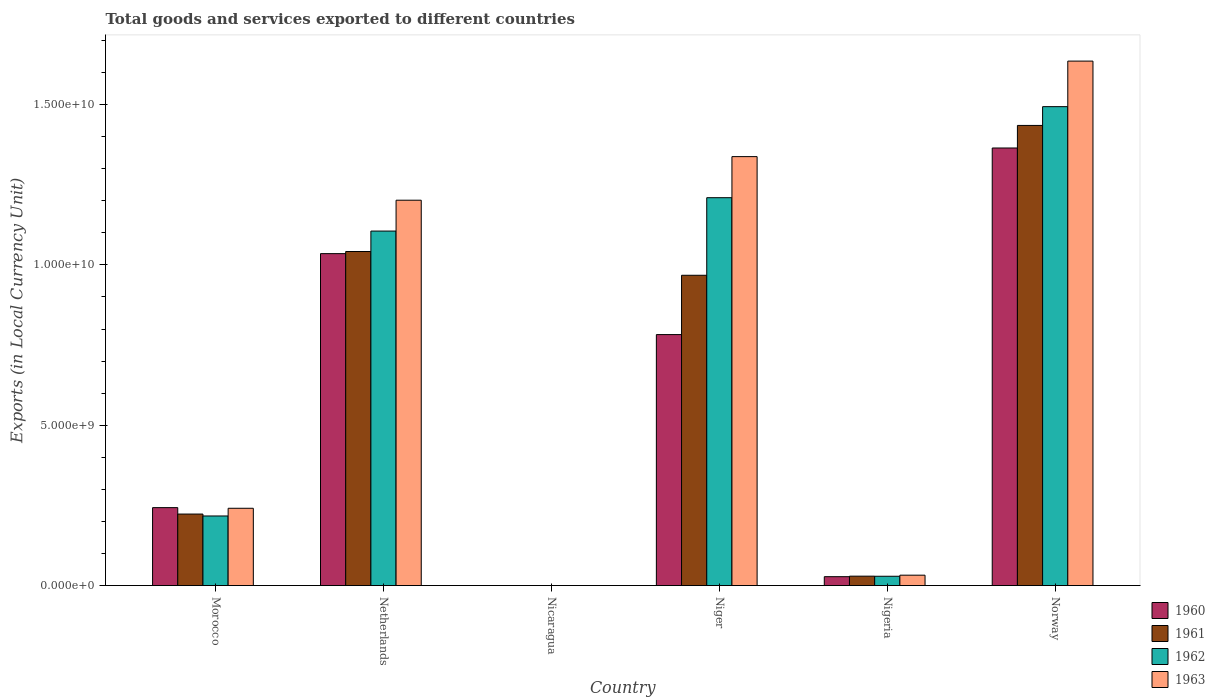How many different coloured bars are there?
Your response must be concise. 4. Are the number of bars per tick equal to the number of legend labels?
Make the answer very short. Yes. Are the number of bars on each tick of the X-axis equal?
Offer a very short reply. Yes. What is the Amount of goods and services exports in 1961 in Nigeria?
Provide a short and direct response. 2.93e+08. Across all countries, what is the maximum Amount of goods and services exports in 1963?
Make the answer very short. 1.64e+1. Across all countries, what is the minimum Amount of goods and services exports in 1963?
Offer a very short reply. 0.18. In which country was the Amount of goods and services exports in 1961 maximum?
Offer a terse response. Norway. In which country was the Amount of goods and services exports in 1963 minimum?
Offer a terse response. Nicaragua. What is the total Amount of goods and services exports in 1960 in the graph?
Make the answer very short. 3.45e+1. What is the difference between the Amount of goods and services exports in 1962 in Nicaragua and that in Niger?
Make the answer very short. -1.21e+1. What is the difference between the Amount of goods and services exports in 1960 in Nicaragua and the Amount of goods and services exports in 1961 in Morocco?
Provide a short and direct response. -2.23e+09. What is the average Amount of goods and services exports in 1963 per country?
Keep it short and to the point. 7.41e+09. What is the difference between the Amount of goods and services exports of/in 1961 and Amount of goods and services exports of/in 1962 in Norway?
Offer a terse response. -5.86e+08. In how many countries, is the Amount of goods and services exports in 1963 greater than 15000000000 LCU?
Offer a terse response. 1. What is the ratio of the Amount of goods and services exports in 1961 in Niger to that in Norway?
Offer a very short reply. 0.67. What is the difference between the highest and the second highest Amount of goods and services exports in 1963?
Your response must be concise. 4.34e+09. What is the difference between the highest and the lowest Amount of goods and services exports in 1961?
Your answer should be compact. 1.43e+1. In how many countries, is the Amount of goods and services exports in 1963 greater than the average Amount of goods and services exports in 1963 taken over all countries?
Ensure brevity in your answer.  3. Is the sum of the Amount of goods and services exports in 1961 in Morocco and Netherlands greater than the maximum Amount of goods and services exports in 1963 across all countries?
Your answer should be very brief. No. What does the 4th bar from the left in Netherlands represents?
Make the answer very short. 1963. What does the 2nd bar from the right in Nigeria represents?
Give a very brief answer. 1962. How many bars are there?
Provide a short and direct response. 24. Where does the legend appear in the graph?
Offer a very short reply. Bottom right. How are the legend labels stacked?
Your answer should be very brief. Vertical. What is the title of the graph?
Your response must be concise. Total goods and services exported to different countries. What is the label or title of the Y-axis?
Your response must be concise. Exports (in Local Currency Unit). What is the Exports (in Local Currency Unit) in 1960 in Morocco?
Keep it short and to the point. 2.43e+09. What is the Exports (in Local Currency Unit) of 1961 in Morocco?
Provide a short and direct response. 2.23e+09. What is the Exports (in Local Currency Unit) of 1962 in Morocco?
Provide a succinct answer. 2.17e+09. What is the Exports (in Local Currency Unit) of 1963 in Morocco?
Give a very brief answer. 2.41e+09. What is the Exports (in Local Currency Unit) in 1960 in Netherlands?
Keep it short and to the point. 1.04e+1. What is the Exports (in Local Currency Unit) of 1961 in Netherlands?
Provide a succinct answer. 1.04e+1. What is the Exports (in Local Currency Unit) of 1962 in Netherlands?
Your answer should be compact. 1.11e+1. What is the Exports (in Local Currency Unit) in 1963 in Netherlands?
Your answer should be very brief. 1.20e+1. What is the Exports (in Local Currency Unit) of 1960 in Nicaragua?
Provide a short and direct response. 0.11. What is the Exports (in Local Currency Unit) in 1961 in Nicaragua?
Your answer should be very brief. 0.12. What is the Exports (in Local Currency Unit) of 1962 in Nicaragua?
Offer a very short reply. 0.15. What is the Exports (in Local Currency Unit) of 1963 in Nicaragua?
Keep it short and to the point. 0.18. What is the Exports (in Local Currency Unit) in 1960 in Niger?
Your answer should be very brief. 7.83e+09. What is the Exports (in Local Currency Unit) of 1961 in Niger?
Your response must be concise. 9.68e+09. What is the Exports (in Local Currency Unit) in 1962 in Niger?
Provide a succinct answer. 1.21e+1. What is the Exports (in Local Currency Unit) of 1963 in Niger?
Offer a very short reply. 1.34e+1. What is the Exports (in Local Currency Unit) of 1960 in Nigeria?
Offer a terse response. 2.77e+08. What is the Exports (in Local Currency Unit) in 1961 in Nigeria?
Offer a terse response. 2.93e+08. What is the Exports (in Local Currency Unit) in 1962 in Nigeria?
Provide a short and direct response. 2.90e+08. What is the Exports (in Local Currency Unit) of 1963 in Nigeria?
Offer a terse response. 3.24e+08. What is the Exports (in Local Currency Unit) of 1960 in Norway?
Keep it short and to the point. 1.36e+1. What is the Exports (in Local Currency Unit) in 1961 in Norway?
Your answer should be very brief. 1.43e+1. What is the Exports (in Local Currency Unit) in 1962 in Norway?
Your answer should be very brief. 1.49e+1. What is the Exports (in Local Currency Unit) of 1963 in Norway?
Offer a terse response. 1.64e+1. Across all countries, what is the maximum Exports (in Local Currency Unit) of 1960?
Give a very brief answer. 1.36e+1. Across all countries, what is the maximum Exports (in Local Currency Unit) of 1961?
Your response must be concise. 1.43e+1. Across all countries, what is the maximum Exports (in Local Currency Unit) in 1962?
Your answer should be very brief. 1.49e+1. Across all countries, what is the maximum Exports (in Local Currency Unit) in 1963?
Offer a terse response. 1.64e+1. Across all countries, what is the minimum Exports (in Local Currency Unit) in 1960?
Offer a very short reply. 0.11. Across all countries, what is the minimum Exports (in Local Currency Unit) of 1961?
Ensure brevity in your answer.  0.12. Across all countries, what is the minimum Exports (in Local Currency Unit) in 1962?
Provide a short and direct response. 0.15. Across all countries, what is the minimum Exports (in Local Currency Unit) in 1963?
Your response must be concise. 0.18. What is the total Exports (in Local Currency Unit) in 1960 in the graph?
Your answer should be very brief. 3.45e+1. What is the total Exports (in Local Currency Unit) of 1961 in the graph?
Your answer should be very brief. 3.70e+1. What is the total Exports (in Local Currency Unit) in 1962 in the graph?
Provide a short and direct response. 4.05e+1. What is the total Exports (in Local Currency Unit) in 1963 in the graph?
Your answer should be compact. 4.45e+1. What is the difference between the Exports (in Local Currency Unit) of 1960 in Morocco and that in Netherlands?
Provide a short and direct response. -7.92e+09. What is the difference between the Exports (in Local Currency Unit) in 1961 in Morocco and that in Netherlands?
Keep it short and to the point. -8.19e+09. What is the difference between the Exports (in Local Currency Unit) of 1962 in Morocco and that in Netherlands?
Give a very brief answer. -8.88e+09. What is the difference between the Exports (in Local Currency Unit) in 1963 in Morocco and that in Netherlands?
Give a very brief answer. -9.61e+09. What is the difference between the Exports (in Local Currency Unit) in 1960 in Morocco and that in Nicaragua?
Your response must be concise. 2.43e+09. What is the difference between the Exports (in Local Currency Unit) in 1961 in Morocco and that in Nicaragua?
Provide a succinct answer. 2.23e+09. What is the difference between the Exports (in Local Currency Unit) in 1962 in Morocco and that in Nicaragua?
Make the answer very short. 2.17e+09. What is the difference between the Exports (in Local Currency Unit) in 1963 in Morocco and that in Nicaragua?
Keep it short and to the point. 2.41e+09. What is the difference between the Exports (in Local Currency Unit) in 1960 in Morocco and that in Niger?
Provide a succinct answer. -5.40e+09. What is the difference between the Exports (in Local Currency Unit) of 1961 in Morocco and that in Niger?
Make the answer very short. -7.45e+09. What is the difference between the Exports (in Local Currency Unit) in 1962 in Morocco and that in Niger?
Offer a terse response. -9.92e+09. What is the difference between the Exports (in Local Currency Unit) of 1963 in Morocco and that in Niger?
Offer a very short reply. -1.10e+1. What is the difference between the Exports (in Local Currency Unit) in 1960 in Morocco and that in Nigeria?
Offer a very short reply. 2.15e+09. What is the difference between the Exports (in Local Currency Unit) of 1961 in Morocco and that in Nigeria?
Offer a very short reply. 1.94e+09. What is the difference between the Exports (in Local Currency Unit) in 1962 in Morocco and that in Nigeria?
Make the answer very short. 1.88e+09. What is the difference between the Exports (in Local Currency Unit) in 1963 in Morocco and that in Nigeria?
Make the answer very short. 2.09e+09. What is the difference between the Exports (in Local Currency Unit) in 1960 in Morocco and that in Norway?
Offer a very short reply. -1.12e+1. What is the difference between the Exports (in Local Currency Unit) of 1961 in Morocco and that in Norway?
Ensure brevity in your answer.  -1.21e+1. What is the difference between the Exports (in Local Currency Unit) of 1962 in Morocco and that in Norway?
Provide a succinct answer. -1.28e+1. What is the difference between the Exports (in Local Currency Unit) in 1963 in Morocco and that in Norway?
Ensure brevity in your answer.  -1.39e+1. What is the difference between the Exports (in Local Currency Unit) in 1960 in Netherlands and that in Nicaragua?
Your response must be concise. 1.04e+1. What is the difference between the Exports (in Local Currency Unit) of 1961 in Netherlands and that in Nicaragua?
Provide a short and direct response. 1.04e+1. What is the difference between the Exports (in Local Currency Unit) of 1962 in Netherlands and that in Nicaragua?
Offer a terse response. 1.11e+1. What is the difference between the Exports (in Local Currency Unit) in 1963 in Netherlands and that in Nicaragua?
Provide a succinct answer. 1.20e+1. What is the difference between the Exports (in Local Currency Unit) of 1960 in Netherlands and that in Niger?
Offer a very short reply. 2.52e+09. What is the difference between the Exports (in Local Currency Unit) in 1961 in Netherlands and that in Niger?
Keep it short and to the point. 7.41e+08. What is the difference between the Exports (in Local Currency Unit) in 1962 in Netherlands and that in Niger?
Keep it short and to the point. -1.04e+09. What is the difference between the Exports (in Local Currency Unit) of 1963 in Netherlands and that in Niger?
Provide a succinct answer. -1.36e+09. What is the difference between the Exports (in Local Currency Unit) of 1960 in Netherlands and that in Nigeria?
Provide a succinct answer. 1.01e+1. What is the difference between the Exports (in Local Currency Unit) of 1961 in Netherlands and that in Nigeria?
Offer a terse response. 1.01e+1. What is the difference between the Exports (in Local Currency Unit) of 1962 in Netherlands and that in Nigeria?
Give a very brief answer. 1.08e+1. What is the difference between the Exports (in Local Currency Unit) of 1963 in Netherlands and that in Nigeria?
Provide a short and direct response. 1.17e+1. What is the difference between the Exports (in Local Currency Unit) of 1960 in Netherlands and that in Norway?
Keep it short and to the point. -3.29e+09. What is the difference between the Exports (in Local Currency Unit) in 1961 in Netherlands and that in Norway?
Your answer should be very brief. -3.93e+09. What is the difference between the Exports (in Local Currency Unit) of 1962 in Netherlands and that in Norway?
Your answer should be very brief. -3.88e+09. What is the difference between the Exports (in Local Currency Unit) in 1963 in Netherlands and that in Norway?
Your answer should be very brief. -4.34e+09. What is the difference between the Exports (in Local Currency Unit) in 1960 in Nicaragua and that in Niger?
Provide a short and direct response. -7.83e+09. What is the difference between the Exports (in Local Currency Unit) of 1961 in Nicaragua and that in Niger?
Provide a short and direct response. -9.68e+09. What is the difference between the Exports (in Local Currency Unit) in 1962 in Nicaragua and that in Niger?
Your answer should be very brief. -1.21e+1. What is the difference between the Exports (in Local Currency Unit) of 1963 in Nicaragua and that in Niger?
Make the answer very short. -1.34e+1. What is the difference between the Exports (in Local Currency Unit) of 1960 in Nicaragua and that in Nigeria?
Keep it short and to the point. -2.77e+08. What is the difference between the Exports (in Local Currency Unit) in 1961 in Nicaragua and that in Nigeria?
Your response must be concise. -2.93e+08. What is the difference between the Exports (in Local Currency Unit) of 1962 in Nicaragua and that in Nigeria?
Make the answer very short. -2.90e+08. What is the difference between the Exports (in Local Currency Unit) in 1963 in Nicaragua and that in Nigeria?
Offer a very short reply. -3.24e+08. What is the difference between the Exports (in Local Currency Unit) of 1960 in Nicaragua and that in Norway?
Provide a short and direct response. -1.36e+1. What is the difference between the Exports (in Local Currency Unit) in 1961 in Nicaragua and that in Norway?
Give a very brief answer. -1.43e+1. What is the difference between the Exports (in Local Currency Unit) of 1962 in Nicaragua and that in Norway?
Your answer should be compact. -1.49e+1. What is the difference between the Exports (in Local Currency Unit) of 1963 in Nicaragua and that in Norway?
Offer a terse response. -1.64e+1. What is the difference between the Exports (in Local Currency Unit) in 1960 in Niger and that in Nigeria?
Provide a short and direct response. 7.55e+09. What is the difference between the Exports (in Local Currency Unit) of 1961 in Niger and that in Nigeria?
Your answer should be compact. 9.38e+09. What is the difference between the Exports (in Local Currency Unit) in 1962 in Niger and that in Nigeria?
Offer a very short reply. 1.18e+1. What is the difference between the Exports (in Local Currency Unit) in 1963 in Niger and that in Nigeria?
Offer a terse response. 1.31e+1. What is the difference between the Exports (in Local Currency Unit) in 1960 in Niger and that in Norway?
Provide a succinct answer. -5.82e+09. What is the difference between the Exports (in Local Currency Unit) in 1961 in Niger and that in Norway?
Give a very brief answer. -4.67e+09. What is the difference between the Exports (in Local Currency Unit) of 1962 in Niger and that in Norway?
Keep it short and to the point. -2.84e+09. What is the difference between the Exports (in Local Currency Unit) of 1963 in Niger and that in Norway?
Your answer should be compact. -2.98e+09. What is the difference between the Exports (in Local Currency Unit) in 1960 in Nigeria and that in Norway?
Offer a terse response. -1.34e+1. What is the difference between the Exports (in Local Currency Unit) of 1961 in Nigeria and that in Norway?
Your answer should be very brief. -1.41e+1. What is the difference between the Exports (in Local Currency Unit) in 1962 in Nigeria and that in Norway?
Provide a short and direct response. -1.46e+1. What is the difference between the Exports (in Local Currency Unit) of 1963 in Nigeria and that in Norway?
Make the answer very short. -1.60e+1. What is the difference between the Exports (in Local Currency Unit) of 1960 in Morocco and the Exports (in Local Currency Unit) of 1961 in Netherlands?
Make the answer very short. -7.99e+09. What is the difference between the Exports (in Local Currency Unit) of 1960 in Morocco and the Exports (in Local Currency Unit) of 1962 in Netherlands?
Keep it short and to the point. -8.62e+09. What is the difference between the Exports (in Local Currency Unit) of 1960 in Morocco and the Exports (in Local Currency Unit) of 1963 in Netherlands?
Offer a terse response. -9.59e+09. What is the difference between the Exports (in Local Currency Unit) in 1961 in Morocco and the Exports (in Local Currency Unit) in 1962 in Netherlands?
Provide a succinct answer. -8.82e+09. What is the difference between the Exports (in Local Currency Unit) in 1961 in Morocco and the Exports (in Local Currency Unit) in 1963 in Netherlands?
Provide a succinct answer. -9.79e+09. What is the difference between the Exports (in Local Currency Unit) of 1962 in Morocco and the Exports (in Local Currency Unit) of 1963 in Netherlands?
Offer a terse response. -9.85e+09. What is the difference between the Exports (in Local Currency Unit) in 1960 in Morocco and the Exports (in Local Currency Unit) in 1961 in Nicaragua?
Offer a terse response. 2.43e+09. What is the difference between the Exports (in Local Currency Unit) in 1960 in Morocco and the Exports (in Local Currency Unit) in 1962 in Nicaragua?
Provide a succinct answer. 2.43e+09. What is the difference between the Exports (in Local Currency Unit) in 1960 in Morocco and the Exports (in Local Currency Unit) in 1963 in Nicaragua?
Keep it short and to the point. 2.43e+09. What is the difference between the Exports (in Local Currency Unit) in 1961 in Morocco and the Exports (in Local Currency Unit) in 1962 in Nicaragua?
Your answer should be compact. 2.23e+09. What is the difference between the Exports (in Local Currency Unit) of 1961 in Morocco and the Exports (in Local Currency Unit) of 1963 in Nicaragua?
Ensure brevity in your answer.  2.23e+09. What is the difference between the Exports (in Local Currency Unit) in 1962 in Morocco and the Exports (in Local Currency Unit) in 1963 in Nicaragua?
Provide a succinct answer. 2.17e+09. What is the difference between the Exports (in Local Currency Unit) of 1960 in Morocco and the Exports (in Local Currency Unit) of 1961 in Niger?
Your answer should be compact. -7.25e+09. What is the difference between the Exports (in Local Currency Unit) in 1960 in Morocco and the Exports (in Local Currency Unit) in 1962 in Niger?
Offer a terse response. -9.66e+09. What is the difference between the Exports (in Local Currency Unit) in 1960 in Morocco and the Exports (in Local Currency Unit) in 1963 in Niger?
Ensure brevity in your answer.  -1.09e+1. What is the difference between the Exports (in Local Currency Unit) of 1961 in Morocco and the Exports (in Local Currency Unit) of 1962 in Niger?
Provide a short and direct response. -9.86e+09. What is the difference between the Exports (in Local Currency Unit) in 1961 in Morocco and the Exports (in Local Currency Unit) in 1963 in Niger?
Offer a terse response. -1.11e+1. What is the difference between the Exports (in Local Currency Unit) of 1962 in Morocco and the Exports (in Local Currency Unit) of 1963 in Niger?
Your response must be concise. -1.12e+1. What is the difference between the Exports (in Local Currency Unit) in 1960 in Morocco and the Exports (in Local Currency Unit) in 1961 in Nigeria?
Give a very brief answer. 2.14e+09. What is the difference between the Exports (in Local Currency Unit) of 1960 in Morocco and the Exports (in Local Currency Unit) of 1962 in Nigeria?
Your answer should be compact. 2.14e+09. What is the difference between the Exports (in Local Currency Unit) in 1960 in Morocco and the Exports (in Local Currency Unit) in 1963 in Nigeria?
Your response must be concise. 2.11e+09. What is the difference between the Exports (in Local Currency Unit) in 1961 in Morocco and the Exports (in Local Currency Unit) in 1962 in Nigeria?
Your response must be concise. 1.94e+09. What is the difference between the Exports (in Local Currency Unit) of 1961 in Morocco and the Exports (in Local Currency Unit) of 1963 in Nigeria?
Ensure brevity in your answer.  1.91e+09. What is the difference between the Exports (in Local Currency Unit) of 1962 in Morocco and the Exports (in Local Currency Unit) of 1963 in Nigeria?
Offer a very short reply. 1.85e+09. What is the difference between the Exports (in Local Currency Unit) of 1960 in Morocco and the Exports (in Local Currency Unit) of 1961 in Norway?
Your response must be concise. -1.19e+1. What is the difference between the Exports (in Local Currency Unit) of 1960 in Morocco and the Exports (in Local Currency Unit) of 1962 in Norway?
Make the answer very short. -1.25e+1. What is the difference between the Exports (in Local Currency Unit) of 1960 in Morocco and the Exports (in Local Currency Unit) of 1963 in Norway?
Ensure brevity in your answer.  -1.39e+1. What is the difference between the Exports (in Local Currency Unit) in 1961 in Morocco and the Exports (in Local Currency Unit) in 1962 in Norway?
Give a very brief answer. -1.27e+1. What is the difference between the Exports (in Local Currency Unit) in 1961 in Morocco and the Exports (in Local Currency Unit) in 1963 in Norway?
Offer a terse response. -1.41e+1. What is the difference between the Exports (in Local Currency Unit) in 1962 in Morocco and the Exports (in Local Currency Unit) in 1963 in Norway?
Make the answer very short. -1.42e+1. What is the difference between the Exports (in Local Currency Unit) in 1960 in Netherlands and the Exports (in Local Currency Unit) in 1961 in Nicaragua?
Offer a very short reply. 1.04e+1. What is the difference between the Exports (in Local Currency Unit) of 1960 in Netherlands and the Exports (in Local Currency Unit) of 1962 in Nicaragua?
Your answer should be compact. 1.04e+1. What is the difference between the Exports (in Local Currency Unit) in 1960 in Netherlands and the Exports (in Local Currency Unit) in 1963 in Nicaragua?
Your response must be concise. 1.04e+1. What is the difference between the Exports (in Local Currency Unit) of 1961 in Netherlands and the Exports (in Local Currency Unit) of 1962 in Nicaragua?
Provide a succinct answer. 1.04e+1. What is the difference between the Exports (in Local Currency Unit) of 1961 in Netherlands and the Exports (in Local Currency Unit) of 1963 in Nicaragua?
Offer a very short reply. 1.04e+1. What is the difference between the Exports (in Local Currency Unit) of 1962 in Netherlands and the Exports (in Local Currency Unit) of 1963 in Nicaragua?
Ensure brevity in your answer.  1.11e+1. What is the difference between the Exports (in Local Currency Unit) of 1960 in Netherlands and the Exports (in Local Currency Unit) of 1961 in Niger?
Offer a very short reply. 6.75e+08. What is the difference between the Exports (in Local Currency Unit) in 1960 in Netherlands and the Exports (in Local Currency Unit) in 1962 in Niger?
Make the answer very short. -1.74e+09. What is the difference between the Exports (in Local Currency Unit) of 1960 in Netherlands and the Exports (in Local Currency Unit) of 1963 in Niger?
Ensure brevity in your answer.  -3.02e+09. What is the difference between the Exports (in Local Currency Unit) in 1961 in Netherlands and the Exports (in Local Currency Unit) in 1962 in Niger?
Provide a short and direct response. -1.68e+09. What is the difference between the Exports (in Local Currency Unit) of 1961 in Netherlands and the Exports (in Local Currency Unit) of 1963 in Niger?
Your response must be concise. -2.96e+09. What is the difference between the Exports (in Local Currency Unit) of 1962 in Netherlands and the Exports (in Local Currency Unit) of 1963 in Niger?
Your answer should be very brief. -2.32e+09. What is the difference between the Exports (in Local Currency Unit) in 1960 in Netherlands and the Exports (in Local Currency Unit) in 1961 in Nigeria?
Provide a succinct answer. 1.01e+1. What is the difference between the Exports (in Local Currency Unit) in 1960 in Netherlands and the Exports (in Local Currency Unit) in 1962 in Nigeria?
Offer a terse response. 1.01e+1. What is the difference between the Exports (in Local Currency Unit) of 1960 in Netherlands and the Exports (in Local Currency Unit) of 1963 in Nigeria?
Provide a short and direct response. 1.00e+1. What is the difference between the Exports (in Local Currency Unit) in 1961 in Netherlands and the Exports (in Local Currency Unit) in 1962 in Nigeria?
Provide a short and direct response. 1.01e+1. What is the difference between the Exports (in Local Currency Unit) in 1961 in Netherlands and the Exports (in Local Currency Unit) in 1963 in Nigeria?
Make the answer very short. 1.01e+1. What is the difference between the Exports (in Local Currency Unit) in 1962 in Netherlands and the Exports (in Local Currency Unit) in 1963 in Nigeria?
Make the answer very short. 1.07e+1. What is the difference between the Exports (in Local Currency Unit) in 1960 in Netherlands and the Exports (in Local Currency Unit) in 1961 in Norway?
Your answer should be compact. -4.00e+09. What is the difference between the Exports (in Local Currency Unit) of 1960 in Netherlands and the Exports (in Local Currency Unit) of 1962 in Norway?
Ensure brevity in your answer.  -4.58e+09. What is the difference between the Exports (in Local Currency Unit) of 1960 in Netherlands and the Exports (in Local Currency Unit) of 1963 in Norway?
Your answer should be very brief. -6.00e+09. What is the difference between the Exports (in Local Currency Unit) of 1961 in Netherlands and the Exports (in Local Currency Unit) of 1962 in Norway?
Ensure brevity in your answer.  -4.52e+09. What is the difference between the Exports (in Local Currency Unit) of 1961 in Netherlands and the Exports (in Local Currency Unit) of 1963 in Norway?
Your answer should be compact. -5.94e+09. What is the difference between the Exports (in Local Currency Unit) in 1962 in Netherlands and the Exports (in Local Currency Unit) in 1963 in Norway?
Your answer should be very brief. -5.30e+09. What is the difference between the Exports (in Local Currency Unit) of 1960 in Nicaragua and the Exports (in Local Currency Unit) of 1961 in Niger?
Provide a succinct answer. -9.68e+09. What is the difference between the Exports (in Local Currency Unit) in 1960 in Nicaragua and the Exports (in Local Currency Unit) in 1962 in Niger?
Give a very brief answer. -1.21e+1. What is the difference between the Exports (in Local Currency Unit) of 1960 in Nicaragua and the Exports (in Local Currency Unit) of 1963 in Niger?
Ensure brevity in your answer.  -1.34e+1. What is the difference between the Exports (in Local Currency Unit) of 1961 in Nicaragua and the Exports (in Local Currency Unit) of 1962 in Niger?
Ensure brevity in your answer.  -1.21e+1. What is the difference between the Exports (in Local Currency Unit) in 1961 in Nicaragua and the Exports (in Local Currency Unit) in 1963 in Niger?
Ensure brevity in your answer.  -1.34e+1. What is the difference between the Exports (in Local Currency Unit) of 1962 in Nicaragua and the Exports (in Local Currency Unit) of 1963 in Niger?
Make the answer very short. -1.34e+1. What is the difference between the Exports (in Local Currency Unit) in 1960 in Nicaragua and the Exports (in Local Currency Unit) in 1961 in Nigeria?
Make the answer very short. -2.93e+08. What is the difference between the Exports (in Local Currency Unit) of 1960 in Nicaragua and the Exports (in Local Currency Unit) of 1962 in Nigeria?
Offer a very short reply. -2.90e+08. What is the difference between the Exports (in Local Currency Unit) of 1960 in Nicaragua and the Exports (in Local Currency Unit) of 1963 in Nigeria?
Ensure brevity in your answer.  -3.24e+08. What is the difference between the Exports (in Local Currency Unit) of 1961 in Nicaragua and the Exports (in Local Currency Unit) of 1962 in Nigeria?
Your response must be concise. -2.90e+08. What is the difference between the Exports (in Local Currency Unit) in 1961 in Nicaragua and the Exports (in Local Currency Unit) in 1963 in Nigeria?
Ensure brevity in your answer.  -3.24e+08. What is the difference between the Exports (in Local Currency Unit) of 1962 in Nicaragua and the Exports (in Local Currency Unit) of 1963 in Nigeria?
Your answer should be very brief. -3.24e+08. What is the difference between the Exports (in Local Currency Unit) in 1960 in Nicaragua and the Exports (in Local Currency Unit) in 1961 in Norway?
Provide a succinct answer. -1.43e+1. What is the difference between the Exports (in Local Currency Unit) of 1960 in Nicaragua and the Exports (in Local Currency Unit) of 1962 in Norway?
Keep it short and to the point. -1.49e+1. What is the difference between the Exports (in Local Currency Unit) in 1960 in Nicaragua and the Exports (in Local Currency Unit) in 1963 in Norway?
Keep it short and to the point. -1.64e+1. What is the difference between the Exports (in Local Currency Unit) in 1961 in Nicaragua and the Exports (in Local Currency Unit) in 1962 in Norway?
Your answer should be compact. -1.49e+1. What is the difference between the Exports (in Local Currency Unit) in 1961 in Nicaragua and the Exports (in Local Currency Unit) in 1963 in Norway?
Your answer should be compact. -1.64e+1. What is the difference between the Exports (in Local Currency Unit) in 1962 in Nicaragua and the Exports (in Local Currency Unit) in 1963 in Norway?
Your answer should be compact. -1.64e+1. What is the difference between the Exports (in Local Currency Unit) in 1960 in Niger and the Exports (in Local Currency Unit) in 1961 in Nigeria?
Your response must be concise. 7.53e+09. What is the difference between the Exports (in Local Currency Unit) in 1960 in Niger and the Exports (in Local Currency Unit) in 1962 in Nigeria?
Your response must be concise. 7.54e+09. What is the difference between the Exports (in Local Currency Unit) of 1960 in Niger and the Exports (in Local Currency Unit) of 1963 in Nigeria?
Offer a very short reply. 7.50e+09. What is the difference between the Exports (in Local Currency Unit) of 1961 in Niger and the Exports (in Local Currency Unit) of 1962 in Nigeria?
Offer a terse response. 9.39e+09. What is the difference between the Exports (in Local Currency Unit) of 1961 in Niger and the Exports (in Local Currency Unit) of 1963 in Nigeria?
Ensure brevity in your answer.  9.35e+09. What is the difference between the Exports (in Local Currency Unit) of 1962 in Niger and the Exports (in Local Currency Unit) of 1963 in Nigeria?
Keep it short and to the point. 1.18e+1. What is the difference between the Exports (in Local Currency Unit) in 1960 in Niger and the Exports (in Local Currency Unit) in 1961 in Norway?
Provide a short and direct response. -6.52e+09. What is the difference between the Exports (in Local Currency Unit) of 1960 in Niger and the Exports (in Local Currency Unit) of 1962 in Norway?
Your answer should be compact. -7.11e+09. What is the difference between the Exports (in Local Currency Unit) of 1960 in Niger and the Exports (in Local Currency Unit) of 1963 in Norway?
Offer a very short reply. -8.53e+09. What is the difference between the Exports (in Local Currency Unit) of 1961 in Niger and the Exports (in Local Currency Unit) of 1962 in Norway?
Offer a very short reply. -5.26e+09. What is the difference between the Exports (in Local Currency Unit) of 1961 in Niger and the Exports (in Local Currency Unit) of 1963 in Norway?
Keep it short and to the point. -6.68e+09. What is the difference between the Exports (in Local Currency Unit) in 1962 in Niger and the Exports (in Local Currency Unit) in 1963 in Norway?
Offer a terse response. -4.26e+09. What is the difference between the Exports (in Local Currency Unit) in 1960 in Nigeria and the Exports (in Local Currency Unit) in 1961 in Norway?
Keep it short and to the point. -1.41e+1. What is the difference between the Exports (in Local Currency Unit) in 1960 in Nigeria and the Exports (in Local Currency Unit) in 1962 in Norway?
Offer a terse response. -1.47e+1. What is the difference between the Exports (in Local Currency Unit) in 1960 in Nigeria and the Exports (in Local Currency Unit) in 1963 in Norway?
Offer a terse response. -1.61e+1. What is the difference between the Exports (in Local Currency Unit) of 1961 in Nigeria and the Exports (in Local Currency Unit) of 1962 in Norway?
Ensure brevity in your answer.  -1.46e+1. What is the difference between the Exports (in Local Currency Unit) in 1961 in Nigeria and the Exports (in Local Currency Unit) in 1963 in Norway?
Your answer should be compact. -1.61e+1. What is the difference between the Exports (in Local Currency Unit) of 1962 in Nigeria and the Exports (in Local Currency Unit) of 1963 in Norway?
Your answer should be very brief. -1.61e+1. What is the average Exports (in Local Currency Unit) of 1960 per country?
Provide a succinct answer. 5.75e+09. What is the average Exports (in Local Currency Unit) in 1961 per country?
Your answer should be compact. 6.16e+09. What is the average Exports (in Local Currency Unit) of 1962 per country?
Your answer should be compact. 6.76e+09. What is the average Exports (in Local Currency Unit) in 1963 per country?
Make the answer very short. 7.41e+09. What is the difference between the Exports (in Local Currency Unit) in 1960 and Exports (in Local Currency Unit) in 1961 in Morocco?
Offer a very short reply. 2.00e+08. What is the difference between the Exports (in Local Currency Unit) in 1960 and Exports (in Local Currency Unit) in 1962 in Morocco?
Offer a terse response. 2.60e+08. What is the difference between the Exports (in Local Currency Unit) in 1961 and Exports (in Local Currency Unit) in 1962 in Morocco?
Your answer should be very brief. 6.00e+07. What is the difference between the Exports (in Local Currency Unit) of 1961 and Exports (in Local Currency Unit) of 1963 in Morocco?
Your answer should be compact. -1.80e+08. What is the difference between the Exports (in Local Currency Unit) in 1962 and Exports (in Local Currency Unit) in 1963 in Morocco?
Your response must be concise. -2.40e+08. What is the difference between the Exports (in Local Currency Unit) of 1960 and Exports (in Local Currency Unit) of 1961 in Netherlands?
Ensure brevity in your answer.  -6.60e+07. What is the difference between the Exports (in Local Currency Unit) of 1960 and Exports (in Local Currency Unit) of 1962 in Netherlands?
Your answer should be compact. -7.03e+08. What is the difference between the Exports (in Local Currency Unit) of 1960 and Exports (in Local Currency Unit) of 1963 in Netherlands?
Keep it short and to the point. -1.67e+09. What is the difference between the Exports (in Local Currency Unit) of 1961 and Exports (in Local Currency Unit) of 1962 in Netherlands?
Keep it short and to the point. -6.37e+08. What is the difference between the Exports (in Local Currency Unit) in 1961 and Exports (in Local Currency Unit) in 1963 in Netherlands?
Keep it short and to the point. -1.60e+09. What is the difference between the Exports (in Local Currency Unit) in 1962 and Exports (in Local Currency Unit) in 1963 in Netherlands?
Provide a succinct answer. -9.62e+08. What is the difference between the Exports (in Local Currency Unit) of 1960 and Exports (in Local Currency Unit) of 1961 in Nicaragua?
Your answer should be compact. -0.01. What is the difference between the Exports (in Local Currency Unit) of 1960 and Exports (in Local Currency Unit) of 1962 in Nicaragua?
Your response must be concise. -0.04. What is the difference between the Exports (in Local Currency Unit) in 1960 and Exports (in Local Currency Unit) in 1963 in Nicaragua?
Provide a short and direct response. -0.07. What is the difference between the Exports (in Local Currency Unit) of 1961 and Exports (in Local Currency Unit) of 1962 in Nicaragua?
Your response must be concise. -0.03. What is the difference between the Exports (in Local Currency Unit) in 1961 and Exports (in Local Currency Unit) in 1963 in Nicaragua?
Your answer should be very brief. -0.06. What is the difference between the Exports (in Local Currency Unit) of 1962 and Exports (in Local Currency Unit) of 1963 in Nicaragua?
Offer a very short reply. -0.03. What is the difference between the Exports (in Local Currency Unit) of 1960 and Exports (in Local Currency Unit) of 1961 in Niger?
Provide a short and direct response. -1.85e+09. What is the difference between the Exports (in Local Currency Unit) in 1960 and Exports (in Local Currency Unit) in 1962 in Niger?
Offer a terse response. -4.27e+09. What is the difference between the Exports (in Local Currency Unit) of 1960 and Exports (in Local Currency Unit) of 1963 in Niger?
Keep it short and to the point. -5.55e+09. What is the difference between the Exports (in Local Currency Unit) in 1961 and Exports (in Local Currency Unit) in 1962 in Niger?
Ensure brevity in your answer.  -2.42e+09. What is the difference between the Exports (in Local Currency Unit) of 1961 and Exports (in Local Currency Unit) of 1963 in Niger?
Offer a very short reply. -3.70e+09. What is the difference between the Exports (in Local Currency Unit) in 1962 and Exports (in Local Currency Unit) in 1963 in Niger?
Your answer should be very brief. -1.28e+09. What is the difference between the Exports (in Local Currency Unit) in 1960 and Exports (in Local Currency Unit) in 1961 in Nigeria?
Give a very brief answer. -1.61e+07. What is the difference between the Exports (in Local Currency Unit) in 1960 and Exports (in Local Currency Unit) in 1962 in Nigeria?
Offer a very short reply. -1.30e+07. What is the difference between the Exports (in Local Currency Unit) in 1960 and Exports (in Local Currency Unit) in 1963 in Nigeria?
Make the answer very short. -4.69e+07. What is the difference between the Exports (in Local Currency Unit) of 1961 and Exports (in Local Currency Unit) of 1962 in Nigeria?
Provide a short and direct response. 3.12e+06. What is the difference between the Exports (in Local Currency Unit) of 1961 and Exports (in Local Currency Unit) of 1963 in Nigeria?
Offer a very short reply. -3.08e+07. What is the difference between the Exports (in Local Currency Unit) in 1962 and Exports (in Local Currency Unit) in 1963 in Nigeria?
Offer a terse response. -3.40e+07. What is the difference between the Exports (in Local Currency Unit) in 1960 and Exports (in Local Currency Unit) in 1961 in Norway?
Give a very brief answer. -7.04e+08. What is the difference between the Exports (in Local Currency Unit) of 1960 and Exports (in Local Currency Unit) of 1962 in Norway?
Give a very brief answer. -1.29e+09. What is the difference between the Exports (in Local Currency Unit) in 1960 and Exports (in Local Currency Unit) in 1963 in Norway?
Offer a very short reply. -2.71e+09. What is the difference between the Exports (in Local Currency Unit) in 1961 and Exports (in Local Currency Unit) in 1962 in Norway?
Your answer should be very brief. -5.86e+08. What is the difference between the Exports (in Local Currency Unit) in 1961 and Exports (in Local Currency Unit) in 1963 in Norway?
Provide a short and direct response. -2.01e+09. What is the difference between the Exports (in Local Currency Unit) in 1962 and Exports (in Local Currency Unit) in 1963 in Norway?
Offer a terse response. -1.42e+09. What is the ratio of the Exports (in Local Currency Unit) in 1960 in Morocco to that in Netherlands?
Provide a succinct answer. 0.23. What is the ratio of the Exports (in Local Currency Unit) of 1961 in Morocco to that in Netherlands?
Your response must be concise. 0.21. What is the ratio of the Exports (in Local Currency Unit) in 1962 in Morocco to that in Netherlands?
Keep it short and to the point. 0.2. What is the ratio of the Exports (in Local Currency Unit) of 1963 in Morocco to that in Netherlands?
Ensure brevity in your answer.  0.2. What is the ratio of the Exports (in Local Currency Unit) of 1960 in Morocco to that in Nicaragua?
Keep it short and to the point. 2.19e+1. What is the ratio of the Exports (in Local Currency Unit) in 1961 in Morocco to that in Nicaragua?
Offer a terse response. 1.89e+1. What is the ratio of the Exports (in Local Currency Unit) in 1962 in Morocco to that in Nicaragua?
Give a very brief answer. 1.47e+1. What is the ratio of the Exports (in Local Currency Unit) of 1963 in Morocco to that in Nicaragua?
Give a very brief answer. 1.36e+1. What is the ratio of the Exports (in Local Currency Unit) in 1960 in Morocco to that in Niger?
Make the answer very short. 0.31. What is the ratio of the Exports (in Local Currency Unit) of 1961 in Morocco to that in Niger?
Offer a terse response. 0.23. What is the ratio of the Exports (in Local Currency Unit) in 1962 in Morocco to that in Niger?
Your answer should be very brief. 0.18. What is the ratio of the Exports (in Local Currency Unit) of 1963 in Morocco to that in Niger?
Your answer should be compact. 0.18. What is the ratio of the Exports (in Local Currency Unit) of 1960 in Morocco to that in Nigeria?
Keep it short and to the point. 8.77. What is the ratio of the Exports (in Local Currency Unit) of 1961 in Morocco to that in Nigeria?
Ensure brevity in your answer.  7.61. What is the ratio of the Exports (in Local Currency Unit) in 1962 in Morocco to that in Nigeria?
Provide a short and direct response. 7.48. What is the ratio of the Exports (in Local Currency Unit) in 1963 in Morocco to that in Nigeria?
Your response must be concise. 7.44. What is the ratio of the Exports (in Local Currency Unit) in 1960 in Morocco to that in Norway?
Offer a very short reply. 0.18. What is the ratio of the Exports (in Local Currency Unit) in 1961 in Morocco to that in Norway?
Your response must be concise. 0.16. What is the ratio of the Exports (in Local Currency Unit) of 1962 in Morocco to that in Norway?
Your answer should be compact. 0.15. What is the ratio of the Exports (in Local Currency Unit) in 1963 in Morocco to that in Norway?
Offer a terse response. 0.15. What is the ratio of the Exports (in Local Currency Unit) in 1960 in Netherlands to that in Nicaragua?
Offer a very short reply. 9.31e+1. What is the ratio of the Exports (in Local Currency Unit) in 1961 in Netherlands to that in Nicaragua?
Make the answer very short. 8.81e+1. What is the ratio of the Exports (in Local Currency Unit) of 1962 in Netherlands to that in Nicaragua?
Your response must be concise. 7.51e+1. What is the ratio of the Exports (in Local Currency Unit) in 1963 in Netherlands to that in Nicaragua?
Keep it short and to the point. 6.78e+1. What is the ratio of the Exports (in Local Currency Unit) of 1960 in Netherlands to that in Niger?
Give a very brief answer. 1.32. What is the ratio of the Exports (in Local Currency Unit) in 1961 in Netherlands to that in Niger?
Give a very brief answer. 1.08. What is the ratio of the Exports (in Local Currency Unit) of 1962 in Netherlands to that in Niger?
Make the answer very short. 0.91. What is the ratio of the Exports (in Local Currency Unit) in 1963 in Netherlands to that in Niger?
Make the answer very short. 0.9. What is the ratio of the Exports (in Local Currency Unit) of 1960 in Netherlands to that in Nigeria?
Your answer should be compact. 37.37. What is the ratio of the Exports (in Local Currency Unit) in 1961 in Netherlands to that in Nigeria?
Your answer should be very brief. 35.54. What is the ratio of the Exports (in Local Currency Unit) in 1962 in Netherlands to that in Nigeria?
Give a very brief answer. 38.12. What is the ratio of the Exports (in Local Currency Unit) of 1963 in Netherlands to that in Nigeria?
Provide a short and direct response. 37.1. What is the ratio of the Exports (in Local Currency Unit) of 1960 in Netherlands to that in Norway?
Offer a terse response. 0.76. What is the ratio of the Exports (in Local Currency Unit) in 1961 in Netherlands to that in Norway?
Give a very brief answer. 0.73. What is the ratio of the Exports (in Local Currency Unit) in 1962 in Netherlands to that in Norway?
Your response must be concise. 0.74. What is the ratio of the Exports (in Local Currency Unit) of 1963 in Netherlands to that in Norway?
Your answer should be very brief. 0.73. What is the ratio of the Exports (in Local Currency Unit) of 1960 in Nicaragua to that in Niger?
Provide a short and direct response. 0. What is the ratio of the Exports (in Local Currency Unit) of 1962 in Nicaragua to that in Niger?
Your response must be concise. 0. What is the ratio of the Exports (in Local Currency Unit) of 1963 in Nicaragua to that in Niger?
Your answer should be compact. 0. What is the ratio of the Exports (in Local Currency Unit) of 1960 in Nicaragua to that in Norway?
Your answer should be compact. 0. What is the ratio of the Exports (in Local Currency Unit) in 1962 in Nicaragua to that in Norway?
Make the answer very short. 0. What is the ratio of the Exports (in Local Currency Unit) of 1963 in Nicaragua to that in Norway?
Make the answer very short. 0. What is the ratio of the Exports (in Local Currency Unit) in 1960 in Niger to that in Nigeria?
Offer a very short reply. 28.25. What is the ratio of the Exports (in Local Currency Unit) in 1961 in Niger to that in Nigeria?
Provide a short and direct response. 33.01. What is the ratio of the Exports (in Local Currency Unit) of 1962 in Niger to that in Nigeria?
Give a very brief answer. 41.71. What is the ratio of the Exports (in Local Currency Unit) of 1963 in Niger to that in Nigeria?
Your answer should be very brief. 41.29. What is the ratio of the Exports (in Local Currency Unit) in 1960 in Niger to that in Norway?
Your answer should be compact. 0.57. What is the ratio of the Exports (in Local Currency Unit) in 1961 in Niger to that in Norway?
Provide a short and direct response. 0.67. What is the ratio of the Exports (in Local Currency Unit) in 1962 in Niger to that in Norway?
Provide a short and direct response. 0.81. What is the ratio of the Exports (in Local Currency Unit) of 1963 in Niger to that in Norway?
Provide a short and direct response. 0.82. What is the ratio of the Exports (in Local Currency Unit) of 1960 in Nigeria to that in Norway?
Keep it short and to the point. 0.02. What is the ratio of the Exports (in Local Currency Unit) in 1961 in Nigeria to that in Norway?
Offer a terse response. 0.02. What is the ratio of the Exports (in Local Currency Unit) in 1962 in Nigeria to that in Norway?
Offer a terse response. 0.02. What is the ratio of the Exports (in Local Currency Unit) in 1963 in Nigeria to that in Norway?
Keep it short and to the point. 0.02. What is the difference between the highest and the second highest Exports (in Local Currency Unit) of 1960?
Keep it short and to the point. 3.29e+09. What is the difference between the highest and the second highest Exports (in Local Currency Unit) in 1961?
Make the answer very short. 3.93e+09. What is the difference between the highest and the second highest Exports (in Local Currency Unit) of 1962?
Offer a very short reply. 2.84e+09. What is the difference between the highest and the second highest Exports (in Local Currency Unit) in 1963?
Offer a terse response. 2.98e+09. What is the difference between the highest and the lowest Exports (in Local Currency Unit) of 1960?
Provide a short and direct response. 1.36e+1. What is the difference between the highest and the lowest Exports (in Local Currency Unit) of 1961?
Your answer should be compact. 1.43e+1. What is the difference between the highest and the lowest Exports (in Local Currency Unit) of 1962?
Provide a short and direct response. 1.49e+1. What is the difference between the highest and the lowest Exports (in Local Currency Unit) of 1963?
Your response must be concise. 1.64e+1. 